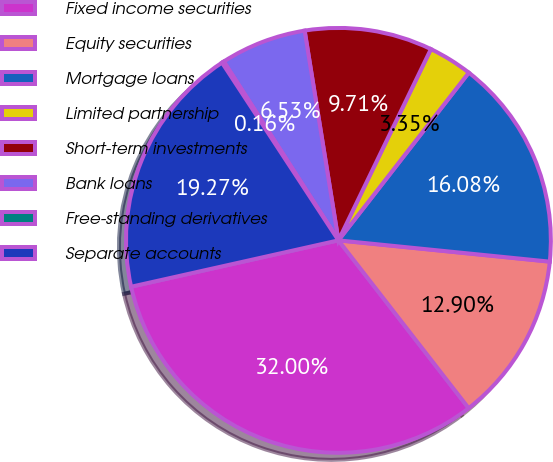Convert chart. <chart><loc_0><loc_0><loc_500><loc_500><pie_chart><fcel>Fixed income securities<fcel>Equity securities<fcel>Mortgage loans<fcel>Limited partnership<fcel>Short-term investments<fcel>Bank loans<fcel>Free-standing derivatives<fcel>Separate accounts<nl><fcel>32.0%<fcel>12.9%<fcel>16.08%<fcel>3.35%<fcel>9.71%<fcel>6.53%<fcel>0.16%<fcel>19.27%<nl></chart> 